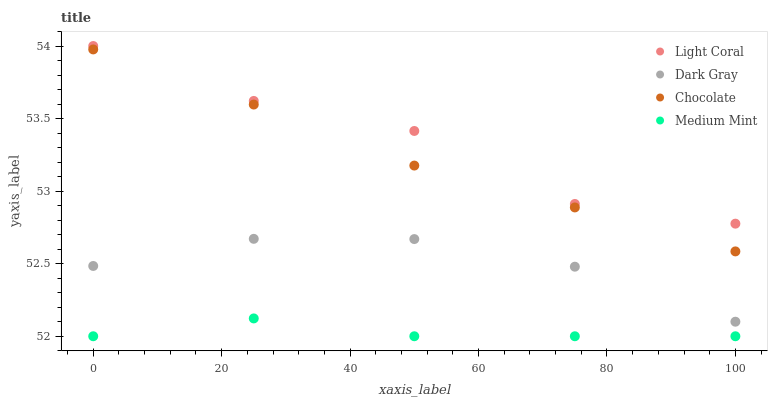Does Medium Mint have the minimum area under the curve?
Answer yes or no. Yes. Does Light Coral have the maximum area under the curve?
Answer yes or no. Yes. Does Dark Gray have the minimum area under the curve?
Answer yes or no. No. Does Dark Gray have the maximum area under the curve?
Answer yes or no. No. Is Chocolate the smoothest?
Answer yes or no. Yes. Is Light Coral the roughest?
Answer yes or no. Yes. Is Dark Gray the smoothest?
Answer yes or no. No. Is Dark Gray the roughest?
Answer yes or no. No. Does Medium Mint have the lowest value?
Answer yes or no. Yes. Does Dark Gray have the lowest value?
Answer yes or no. No. Does Light Coral have the highest value?
Answer yes or no. Yes. Does Dark Gray have the highest value?
Answer yes or no. No. Is Dark Gray less than Light Coral?
Answer yes or no. Yes. Is Light Coral greater than Dark Gray?
Answer yes or no. Yes. Does Dark Gray intersect Light Coral?
Answer yes or no. No. 